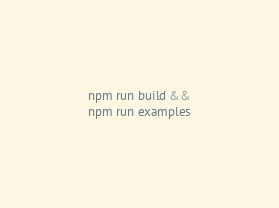<code> <loc_0><loc_0><loc_500><loc_500><_Bash_>npm run build &&
npm run examples</code> 